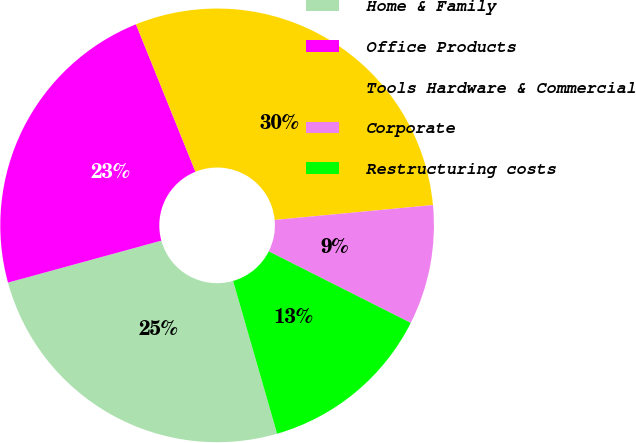<chart> <loc_0><loc_0><loc_500><loc_500><pie_chart><fcel>Home & Family<fcel>Office Products<fcel>Tools Hardware & Commercial<fcel>Corporate<fcel>Restructuring costs<nl><fcel>25.21%<fcel>23.15%<fcel>29.61%<fcel>8.92%<fcel>13.11%<nl></chart> 